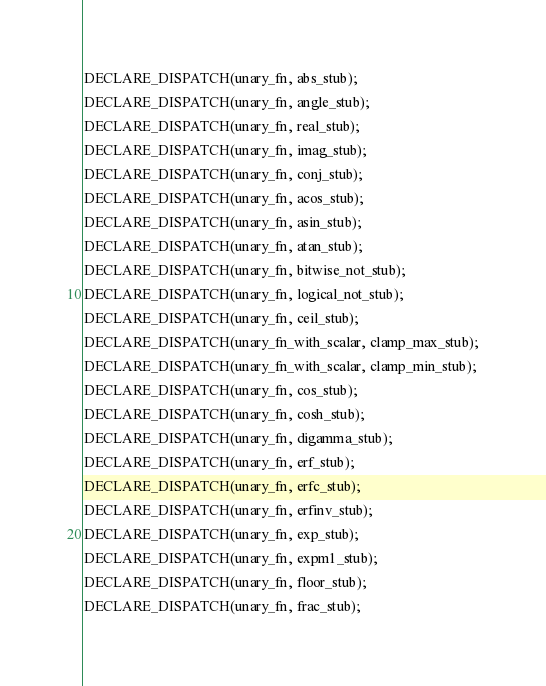Convert code to text. <code><loc_0><loc_0><loc_500><loc_500><_C_>DECLARE_DISPATCH(unary_fn, abs_stub);
DECLARE_DISPATCH(unary_fn, angle_stub);
DECLARE_DISPATCH(unary_fn, real_stub);
DECLARE_DISPATCH(unary_fn, imag_stub);
DECLARE_DISPATCH(unary_fn, conj_stub);
DECLARE_DISPATCH(unary_fn, acos_stub);
DECLARE_DISPATCH(unary_fn, asin_stub);
DECLARE_DISPATCH(unary_fn, atan_stub);
DECLARE_DISPATCH(unary_fn, bitwise_not_stub);
DECLARE_DISPATCH(unary_fn, logical_not_stub);
DECLARE_DISPATCH(unary_fn, ceil_stub);
DECLARE_DISPATCH(unary_fn_with_scalar, clamp_max_stub);
DECLARE_DISPATCH(unary_fn_with_scalar, clamp_min_stub);
DECLARE_DISPATCH(unary_fn, cos_stub);
DECLARE_DISPATCH(unary_fn, cosh_stub);
DECLARE_DISPATCH(unary_fn, digamma_stub);
DECLARE_DISPATCH(unary_fn, erf_stub);
DECLARE_DISPATCH(unary_fn, erfc_stub);
DECLARE_DISPATCH(unary_fn, erfinv_stub);
DECLARE_DISPATCH(unary_fn, exp_stub);
DECLARE_DISPATCH(unary_fn, expm1_stub);
DECLARE_DISPATCH(unary_fn, floor_stub);
DECLARE_DISPATCH(unary_fn, frac_stub);</code> 